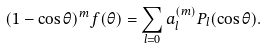Convert formula to latex. <formula><loc_0><loc_0><loc_500><loc_500>( 1 - \cos \theta ) ^ { m } f ( \theta ) = \sum _ { l = 0 } a _ { l } ^ { ( m ) } P _ { l } ( \cos \theta ) .</formula> 